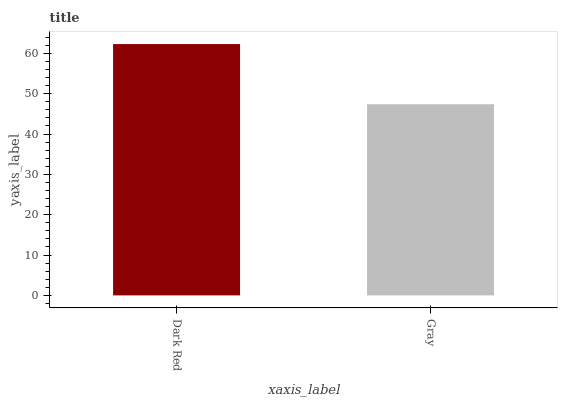Is Gray the minimum?
Answer yes or no. Yes. Is Dark Red the maximum?
Answer yes or no. Yes. Is Gray the maximum?
Answer yes or no. No. Is Dark Red greater than Gray?
Answer yes or no. Yes. Is Gray less than Dark Red?
Answer yes or no. Yes. Is Gray greater than Dark Red?
Answer yes or no. No. Is Dark Red less than Gray?
Answer yes or no. No. Is Dark Red the high median?
Answer yes or no. Yes. Is Gray the low median?
Answer yes or no. Yes. Is Gray the high median?
Answer yes or no. No. Is Dark Red the low median?
Answer yes or no. No. 